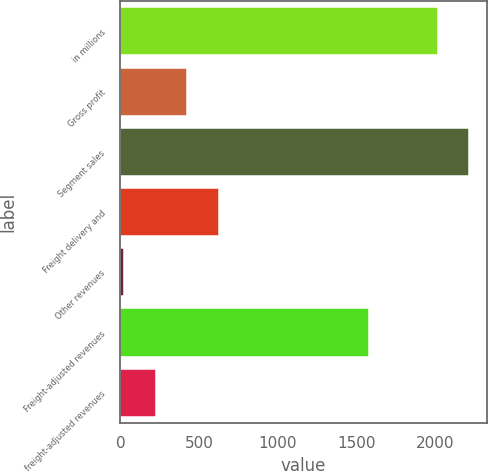Convert chart. <chart><loc_0><loc_0><loc_500><loc_500><bar_chart><fcel>in millions<fcel>Gross profit<fcel>Segment sales<fcel>Freight delivery and<fcel>Other revenues<fcel>Freight-adjusted revenues<fcel>freight-adjusted revenues<nl><fcel>2013<fcel>424.28<fcel>2213.09<fcel>624.37<fcel>24.1<fcel>1576<fcel>224.19<nl></chart> 